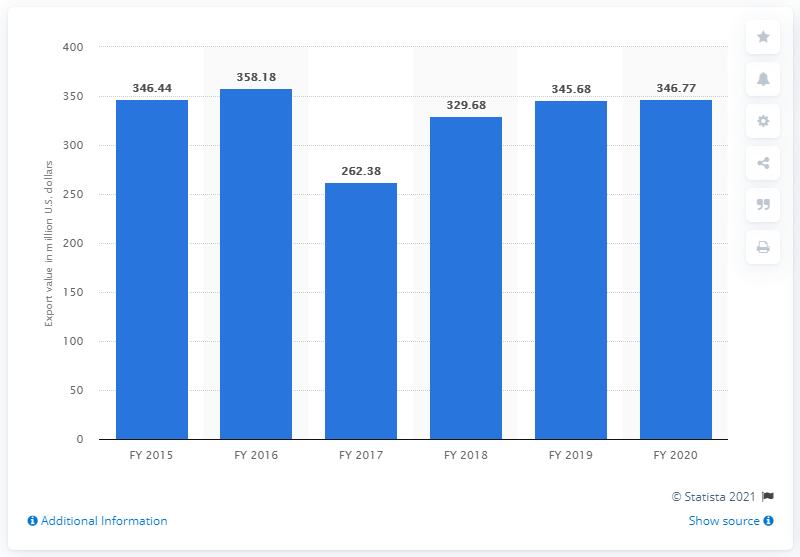Point out several critical features in this image. At the end of the fiscal year 2020, the export value for computer hardware from India was 346.77 million dollars. 